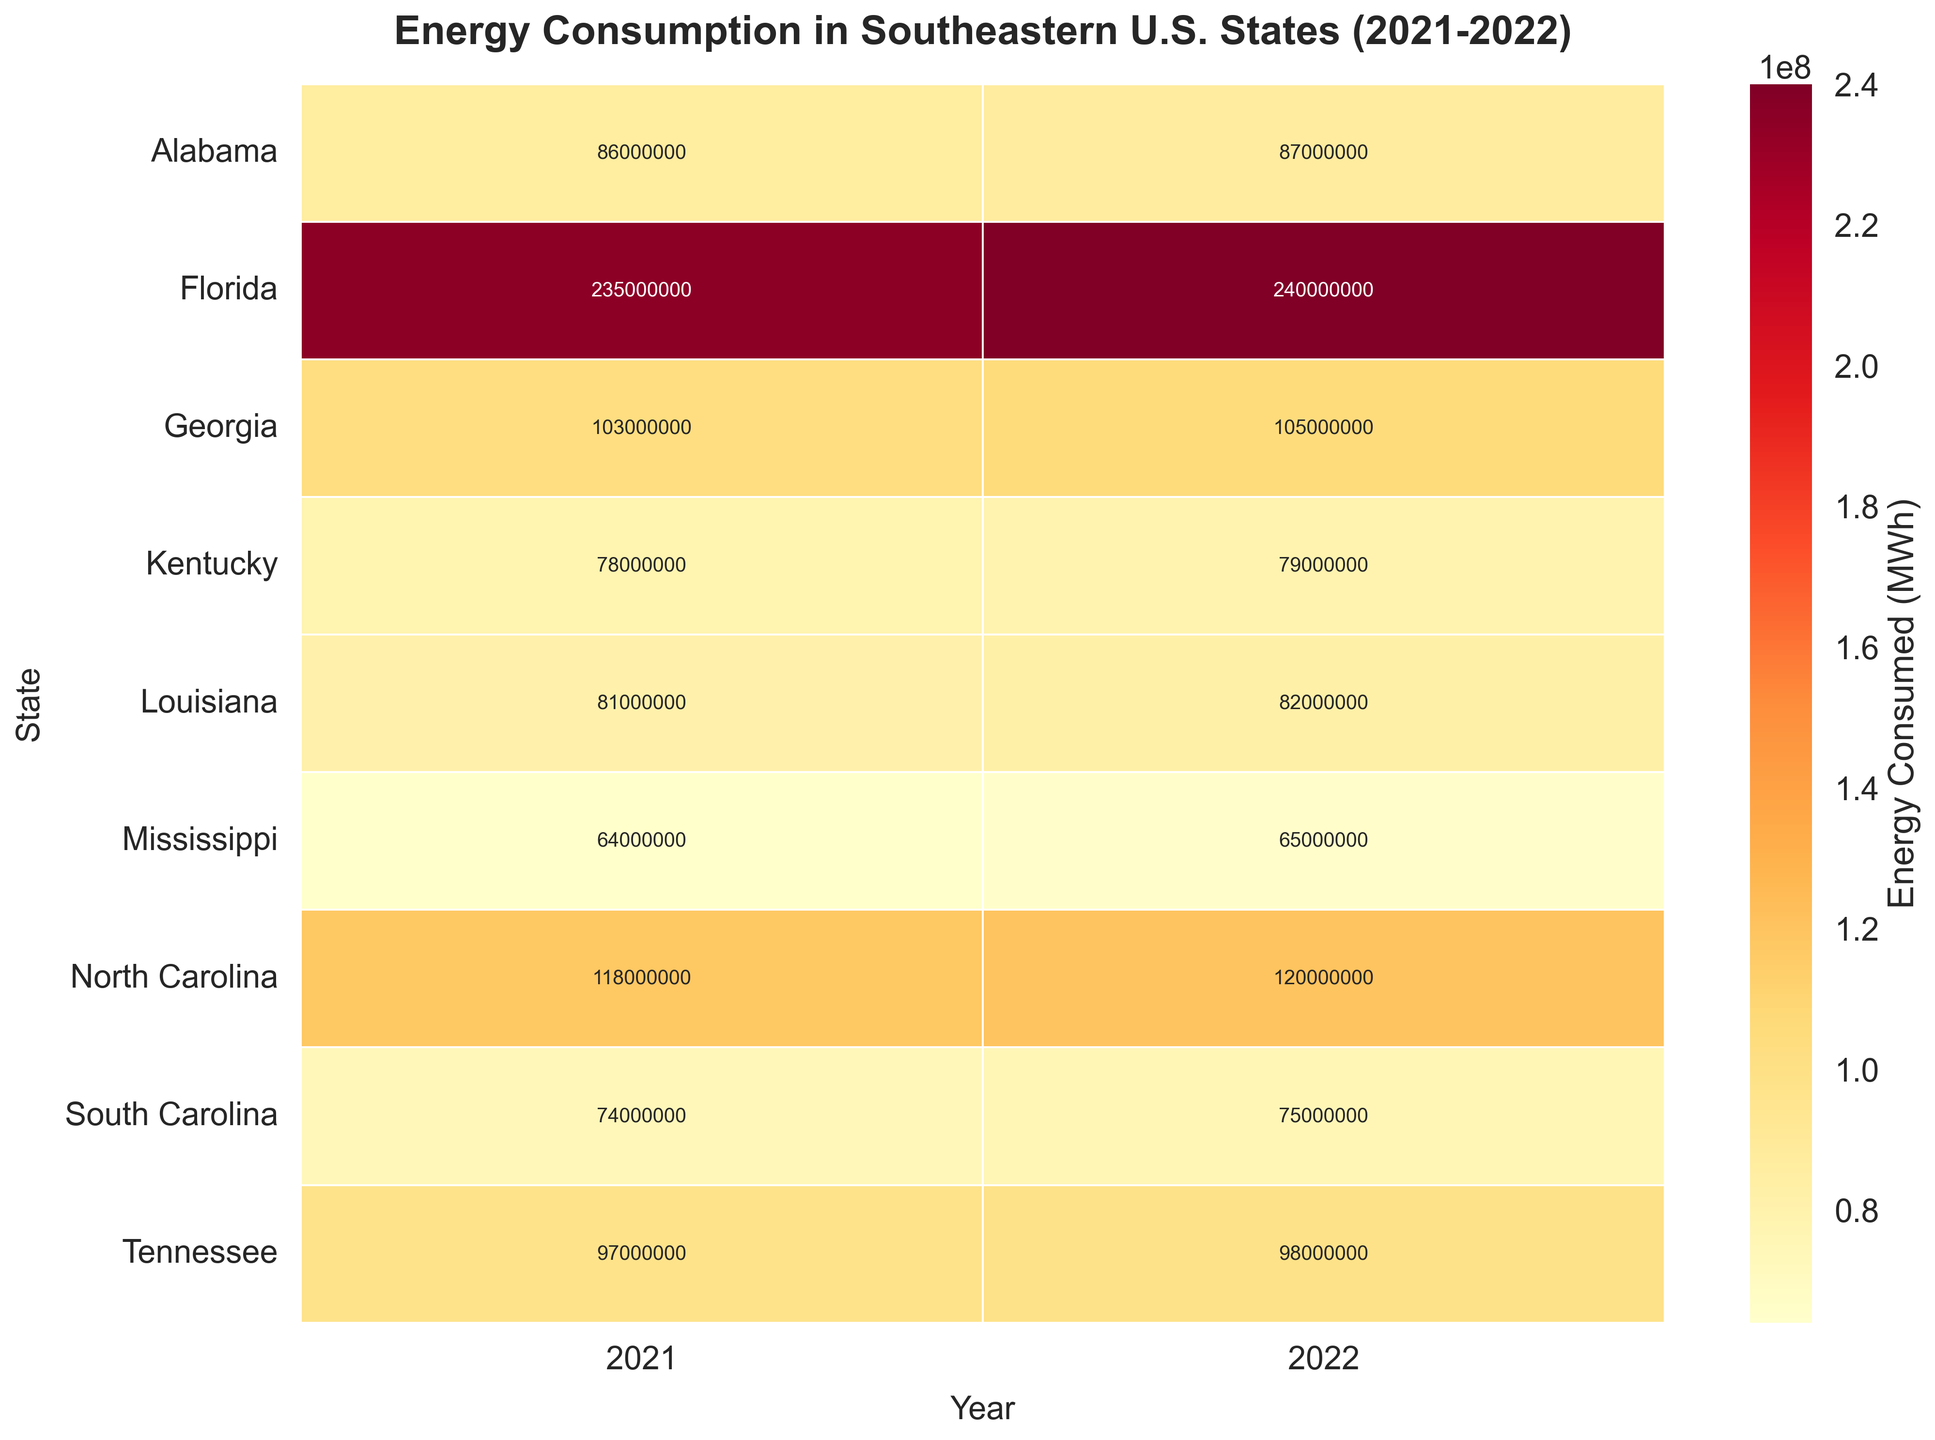What's the title of the heatmap? The title of the heatmap is positioned at the top center of the figure.
Answer: Energy Consumption in Southeastern U.S. States (2021-2022) Which state in 2022 has the highest energy consumption? By looking at the heatmap, find the maximum energy consumption value for the year 2022.
Answer: Florida What's the total energy consumption for South Carolina over both years shown? Sum the energy consumption values for South Carolina for the years 2021 and 2022. So, 74000000 + 75000000 = 149000000.
Answer: 149000000 Comparing 2021 and 2022, which state shows the largest increase in energy consumption? Calculate the difference in energy consumption for each state between 2021 and 2022, and identify the state with the maximum increase. The states' differences are: SC (1000000), NC (2000000), GA (2000000), FL (5000000), AL (1000000), TN (1000000), MS (1000000), KY (1000000), LA (1000000).
Answer: Florida What is the average energy consumption for Georgia across the two years? Calculate the mean of the energy consumption values for Georgia in 2021 and 2022. The values are 103000000 and 105000000, so the average is (103000000 + 105000000) / 2 = 104000000.
Answer: 104000000 Which state has the smallest difference in energy consumption between 2021 and 2022? Find the state with the smallest absolute difference between energy consumption in the two years. The states' differences are: SC (1000000), NC (2000000), GA (2000000), FL (5000000), AL (1000000), TN (1000000), MS (1000000), KY (1000000), LA (1000000). South Carolina, Alabama, Tennessee, Mississippi, Kentucky, and Louisiana all have the smallest difference of 1000000.
Answer: South Carolina, Alabama, Tennessee, Mississippi, Kentucky, Louisiana Is there any state in which energy consumption decreased in 2022 compared to 2021? Compare the energy consumption values for each state between 2021 and 2022.
Answer: No How does the energy consumption of Kentucky in 2021 compare to South Carolina in 2022? Look at the heatmap and compare the specific values. Kentucky in 2021 has 78000000, whereas South Carolina in 2022 has 75000000.
Answer: Kentucky in 2021 is higher What's the range of energy consumption values for Florida from 2021 to 2022? Identify the minimum and maximum values for Florida across the two years, and compute the range by subtracting the minimum value from the maximum value. The values are 235000000 and 240000000, the range is 240000000 - 235000000 = 5000000.
Answer: 5000000 